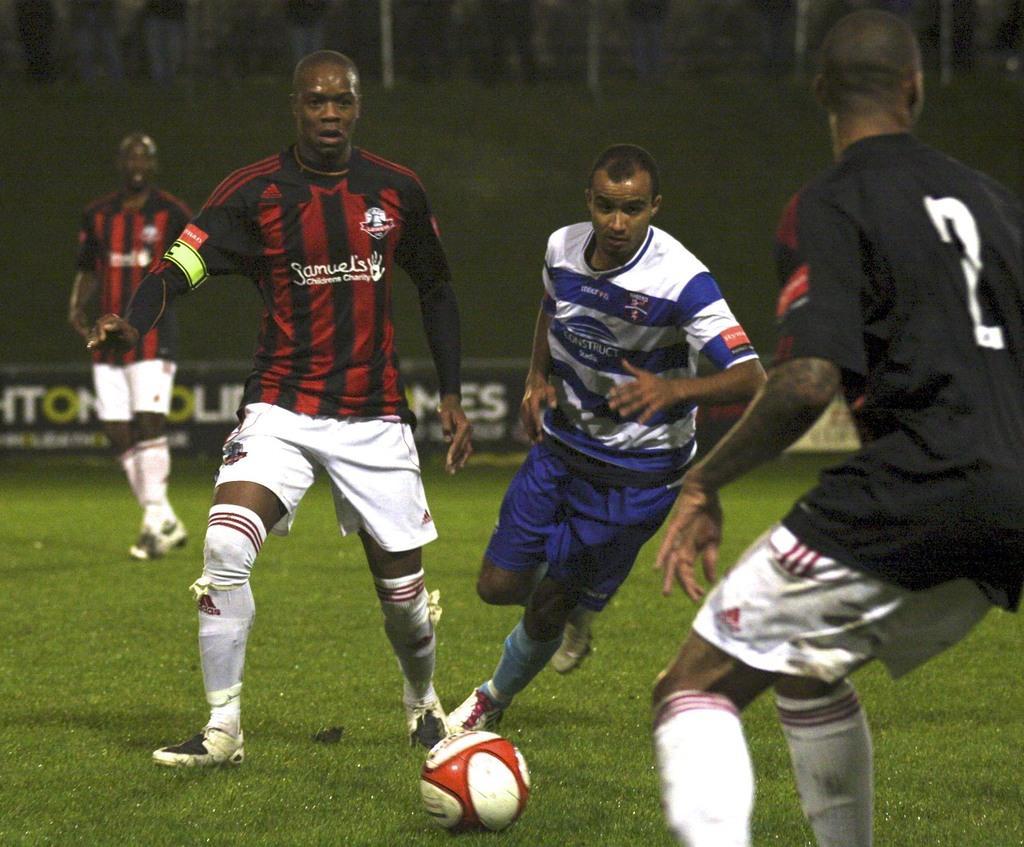How would you summarize this image in a sentence or two? In the center of the image there are people playing football. At the bottom of the image there is grass. 